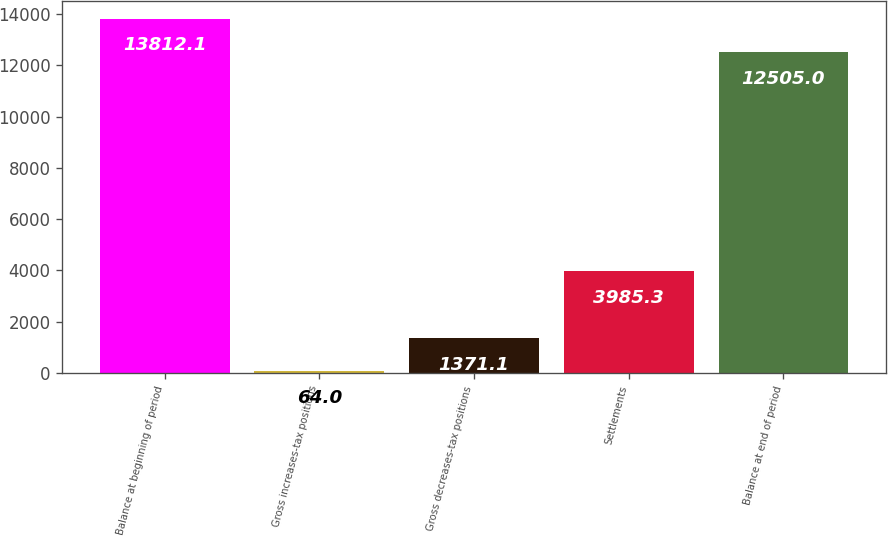Convert chart to OTSL. <chart><loc_0><loc_0><loc_500><loc_500><bar_chart><fcel>Balance at beginning of period<fcel>Gross increases-tax positions<fcel>Gross decreases-tax positions<fcel>Settlements<fcel>Balance at end of period<nl><fcel>13812.1<fcel>64<fcel>1371.1<fcel>3985.3<fcel>12505<nl></chart> 